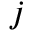<formula> <loc_0><loc_0><loc_500><loc_500>j</formula> 